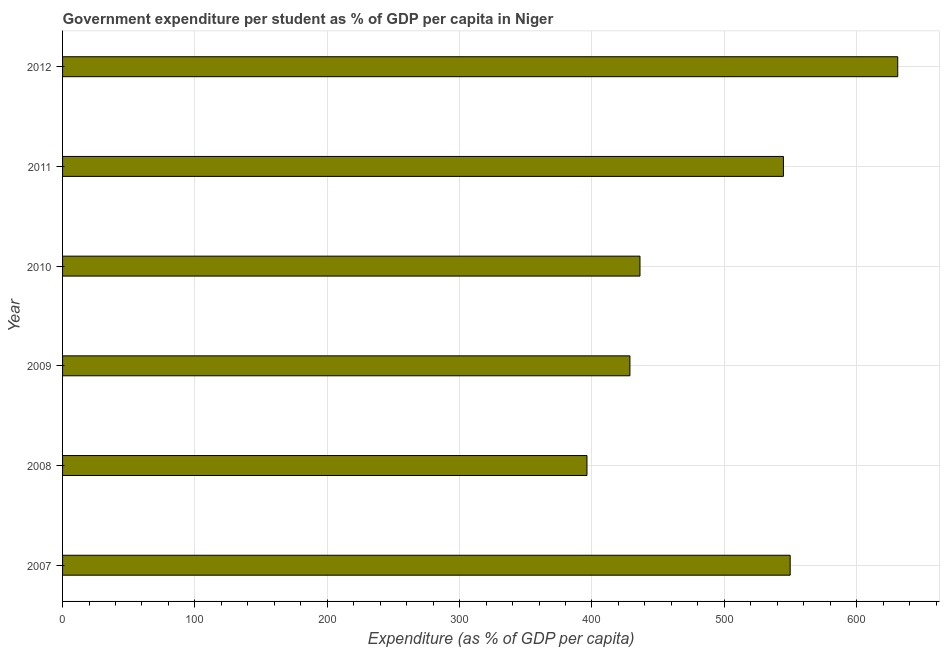Does the graph contain grids?
Offer a terse response. Yes. What is the title of the graph?
Your answer should be compact. Government expenditure per student as % of GDP per capita in Niger. What is the label or title of the X-axis?
Provide a short and direct response. Expenditure (as % of GDP per capita). What is the label or title of the Y-axis?
Your response must be concise. Year. What is the government expenditure per student in 2011?
Ensure brevity in your answer.  544.64. Across all years, what is the maximum government expenditure per student?
Your answer should be very brief. 631. Across all years, what is the minimum government expenditure per student?
Provide a succinct answer. 396.2. In which year was the government expenditure per student minimum?
Give a very brief answer. 2008. What is the sum of the government expenditure per student?
Your answer should be compact. 2986.51. What is the difference between the government expenditure per student in 2011 and 2012?
Provide a succinct answer. -86.36. What is the average government expenditure per student per year?
Your answer should be compact. 497.75. What is the median government expenditure per student?
Your answer should be very brief. 490.45. Do a majority of the years between 2007 and 2012 (inclusive) have government expenditure per student greater than 620 %?
Your response must be concise. No. What is the ratio of the government expenditure per student in 2008 to that in 2010?
Keep it short and to the point. 0.91. Is the difference between the government expenditure per student in 2009 and 2011 greater than the difference between any two years?
Provide a succinct answer. No. What is the difference between the highest and the second highest government expenditure per student?
Provide a short and direct response. 81.27. What is the difference between the highest and the lowest government expenditure per student?
Give a very brief answer. 234.8. In how many years, is the government expenditure per student greater than the average government expenditure per student taken over all years?
Give a very brief answer. 3. How many years are there in the graph?
Provide a succinct answer. 6. Are the values on the major ticks of X-axis written in scientific E-notation?
Make the answer very short. No. What is the Expenditure (as % of GDP per capita) of 2007?
Keep it short and to the point. 549.74. What is the Expenditure (as % of GDP per capita) in 2008?
Ensure brevity in your answer.  396.2. What is the Expenditure (as % of GDP per capita) in 2009?
Ensure brevity in your answer.  428.66. What is the Expenditure (as % of GDP per capita) of 2010?
Keep it short and to the point. 436.26. What is the Expenditure (as % of GDP per capita) in 2011?
Give a very brief answer. 544.64. What is the Expenditure (as % of GDP per capita) in 2012?
Your answer should be compact. 631. What is the difference between the Expenditure (as % of GDP per capita) in 2007 and 2008?
Your response must be concise. 153.53. What is the difference between the Expenditure (as % of GDP per capita) in 2007 and 2009?
Ensure brevity in your answer.  121.08. What is the difference between the Expenditure (as % of GDP per capita) in 2007 and 2010?
Your response must be concise. 113.48. What is the difference between the Expenditure (as % of GDP per capita) in 2007 and 2011?
Your response must be concise. 5.1. What is the difference between the Expenditure (as % of GDP per capita) in 2007 and 2012?
Make the answer very short. -81.27. What is the difference between the Expenditure (as % of GDP per capita) in 2008 and 2009?
Your answer should be very brief. -32.45. What is the difference between the Expenditure (as % of GDP per capita) in 2008 and 2010?
Offer a very short reply. -40.05. What is the difference between the Expenditure (as % of GDP per capita) in 2008 and 2011?
Your answer should be compact. -148.44. What is the difference between the Expenditure (as % of GDP per capita) in 2008 and 2012?
Offer a terse response. -234.8. What is the difference between the Expenditure (as % of GDP per capita) in 2009 and 2010?
Keep it short and to the point. -7.6. What is the difference between the Expenditure (as % of GDP per capita) in 2009 and 2011?
Keep it short and to the point. -115.99. What is the difference between the Expenditure (as % of GDP per capita) in 2009 and 2012?
Offer a terse response. -202.35. What is the difference between the Expenditure (as % of GDP per capita) in 2010 and 2011?
Provide a succinct answer. -108.39. What is the difference between the Expenditure (as % of GDP per capita) in 2010 and 2012?
Provide a short and direct response. -194.75. What is the difference between the Expenditure (as % of GDP per capita) in 2011 and 2012?
Your answer should be compact. -86.36. What is the ratio of the Expenditure (as % of GDP per capita) in 2007 to that in 2008?
Give a very brief answer. 1.39. What is the ratio of the Expenditure (as % of GDP per capita) in 2007 to that in 2009?
Your response must be concise. 1.28. What is the ratio of the Expenditure (as % of GDP per capita) in 2007 to that in 2010?
Give a very brief answer. 1.26. What is the ratio of the Expenditure (as % of GDP per capita) in 2007 to that in 2011?
Offer a terse response. 1.01. What is the ratio of the Expenditure (as % of GDP per capita) in 2007 to that in 2012?
Provide a succinct answer. 0.87. What is the ratio of the Expenditure (as % of GDP per capita) in 2008 to that in 2009?
Provide a succinct answer. 0.92. What is the ratio of the Expenditure (as % of GDP per capita) in 2008 to that in 2010?
Ensure brevity in your answer.  0.91. What is the ratio of the Expenditure (as % of GDP per capita) in 2008 to that in 2011?
Keep it short and to the point. 0.73. What is the ratio of the Expenditure (as % of GDP per capita) in 2008 to that in 2012?
Make the answer very short. 0.63. What is the ratio of the Expenditure (as % of GDP per capita) in 2009 to that in 2011?
Make the answer very short. 0.79. What is the ratio of the Expenditure (as % of GDP per capita) in 2009 to that in 2012?
Keep it short and to the point. 0.68. What is the ratio of the Expenditure (as % of GDP per capita) in 2010 to that in 2011?
Keep it short and to the point. 0.8. What is the ratio of the Expenditure (as % of GDP per capita) in 2010 to that in 2012?
Your response must be concise. 0.69. What is the ratio of the Expenditure (as % of GDP per capita) in 2011 to that in 2012?
Provide a short and direct response. 0.86. 